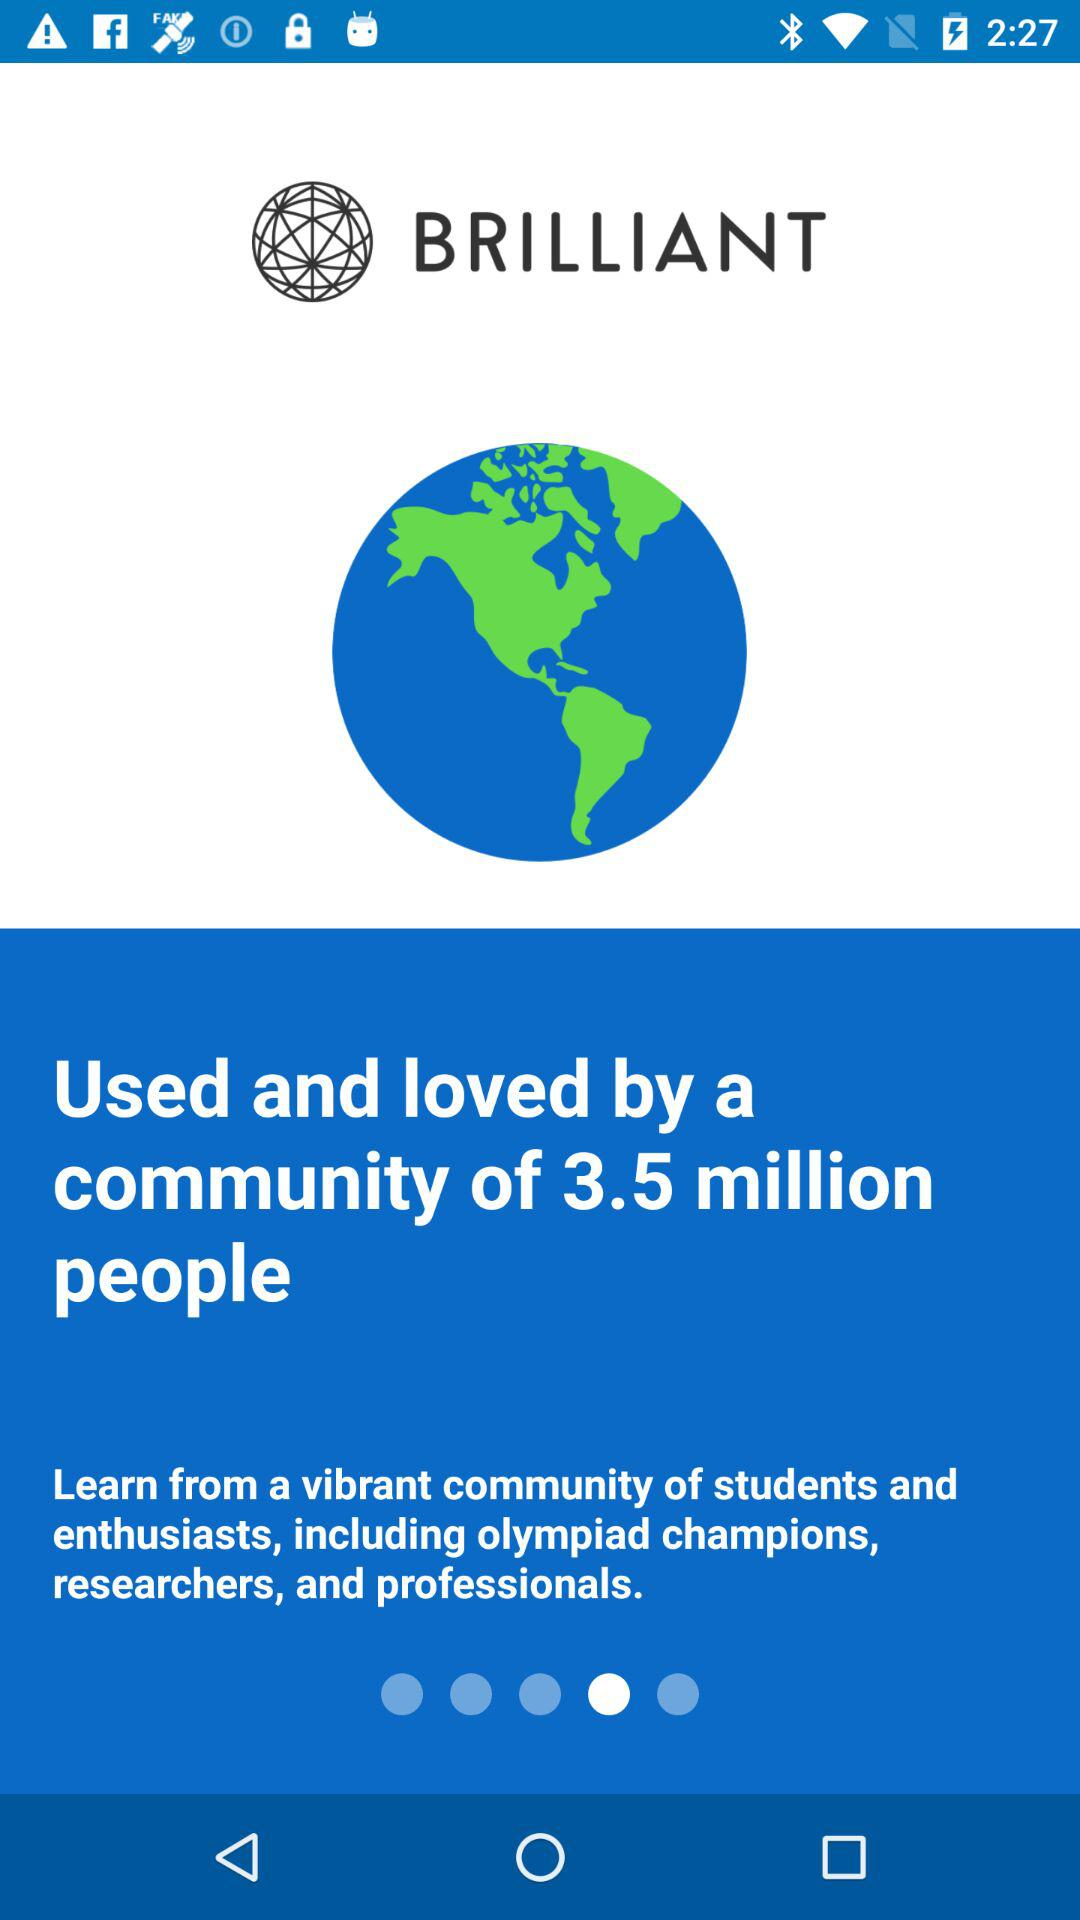Which version of the application is being used?
When the provided information is insufficient, respond with <no answer>. <no answer> 